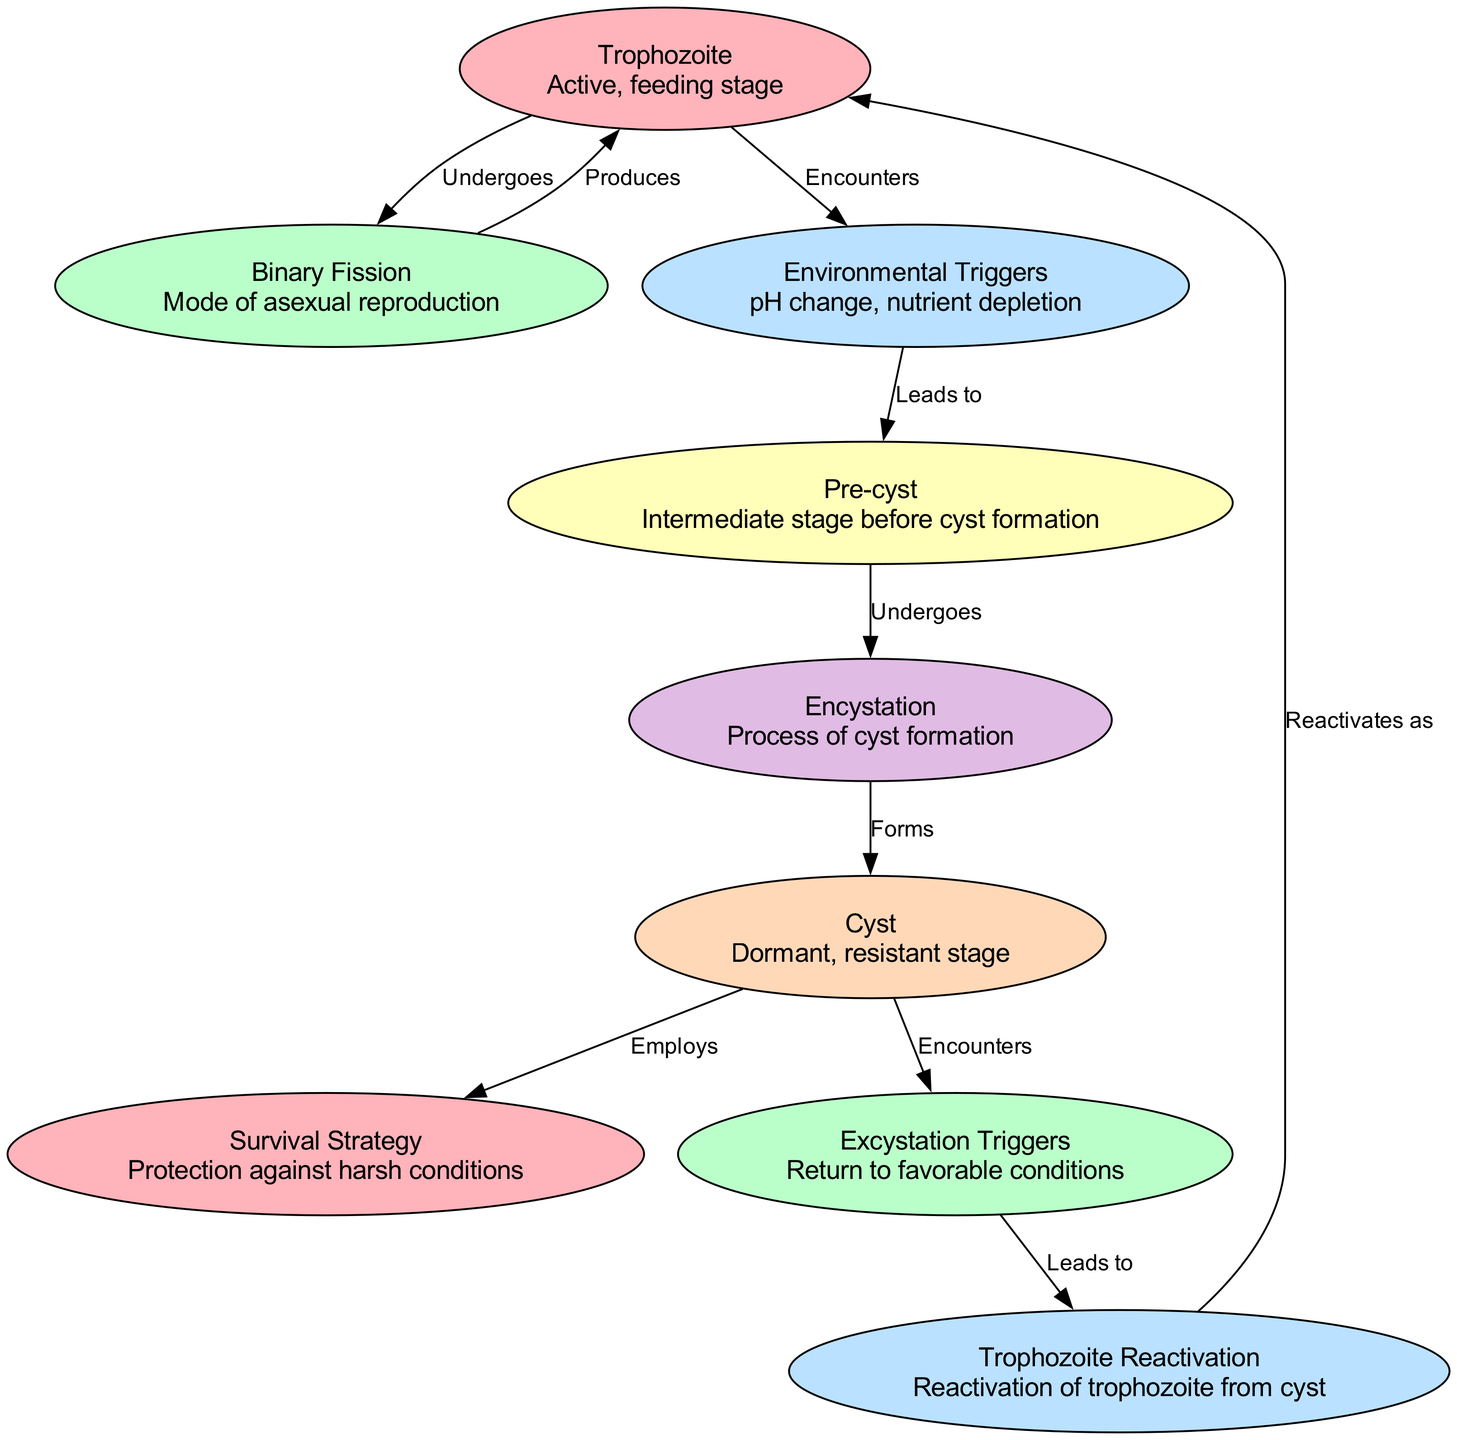What is the active, feeding stage of Pansomonadina? The diagram identifies the trophozoite as the active, feeding stage of Pansomonadina. This information can be found directly labeled in the diagram.
Answer: Trophozoite What process leads to cyst formation? The diagram indicates that the pre-cyst undergoes encystation, which is the process that leads to cyst formation. This relationship is explicitly shown in the flow between those nodes.
Answer: Encystation How many survival strategies are mentioned in the diagram? The diagram lists only one survival strategy associated with the cyst stage. Therefore, we simply count the nodes, and we find one specifically labeled as "Survival Strategy."
Answer: 1 What triggers the reactivation of trophozoites? The diagram specifies that excystation triggers are responsible for leading to trophozoite reactivation. This relationship is clearly defined between the nodes, indicating the connection.
Answer: Excystation Triggers What occurs when trophozoites encounter environmental triggers? According to the diagram, when trophozoites encounter environmental triggers, they lead to the pre-cyst stage. This flow is indicated by the directed edge from the trophozoite to environmental triggers, and then to the pre-cyst node.
Answer: Leads to pre-cyst How are cysts formed from pre-cysts? The diagram states that the pre-cyst undergoes encystation, which is the process through which cysts are finally formed. This progression is visually depicted in the connections between the different nodes.
Answer: Undergoes encystation What is the relationship between cysts and survival strategies? The diagram shows that cysts employ survival strategies, indicating a direct connection where cysts are associated with a certain method or mechanism to withstand harsh environmental conditions.
Answer: Employs What is the mode of asexual reproduction in Pansomonadina? The diagram clearly states "Binary Fission" as the mode of asexual reproduction, derived from the trophozoite, and the explicit labeling makes this information direct and clear.
Answer: Binary Fission 